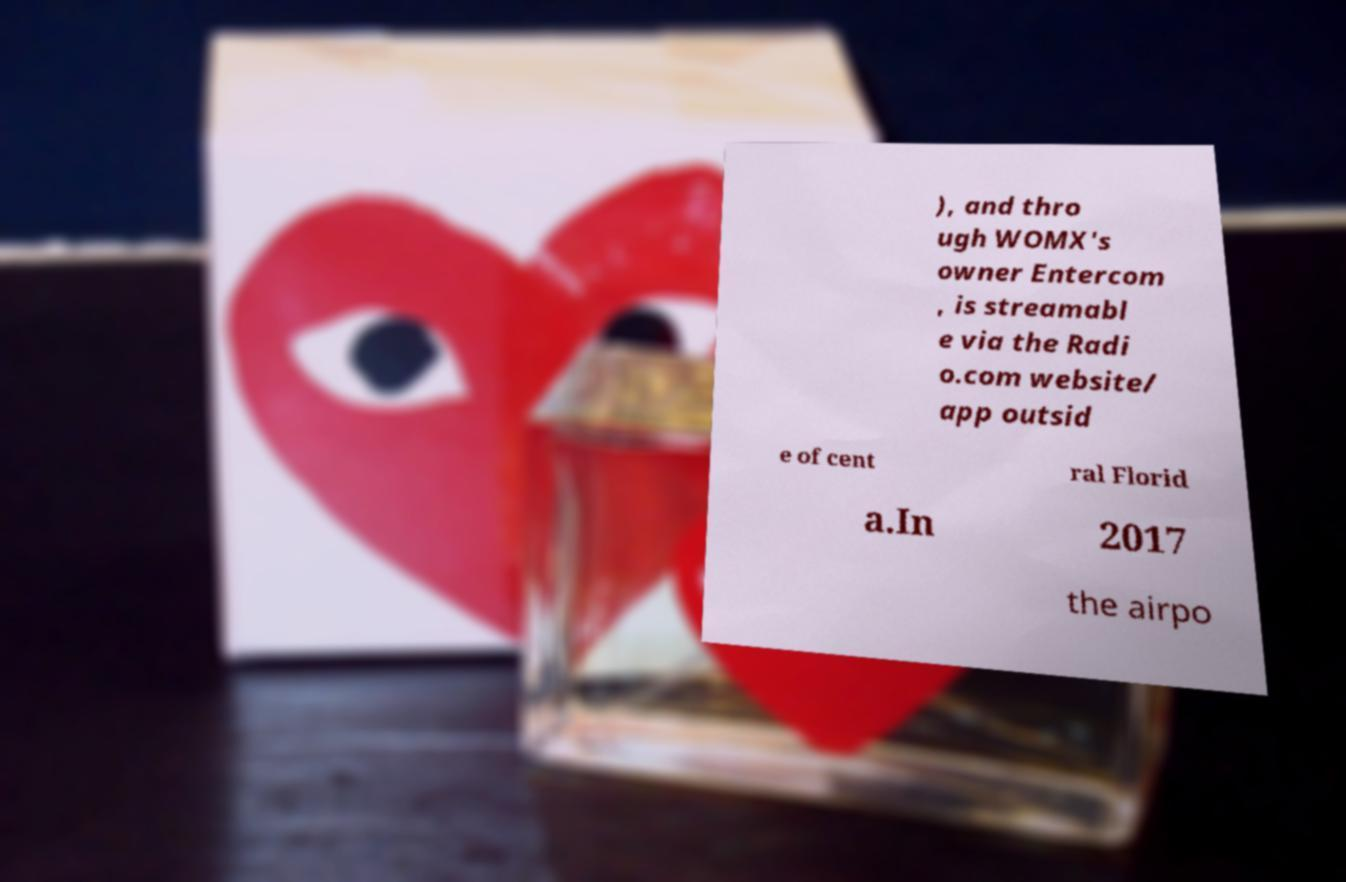Can you accurately transcribe the text from the provided image for me? ), and thro ugh WOMX's owner Entercom , is streamabl e via the Radi o.com website/ app outsid e of cent ral Florid a.In 2017 the airpo 